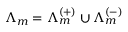<formula> <loc_0><loc_0><loc_500><loc_500>\Lambda _ { m } = \Lambda _ { m } ^ { ( + ) } \cup \Lambda _ { m } ^ { ( - ) }</formula> 